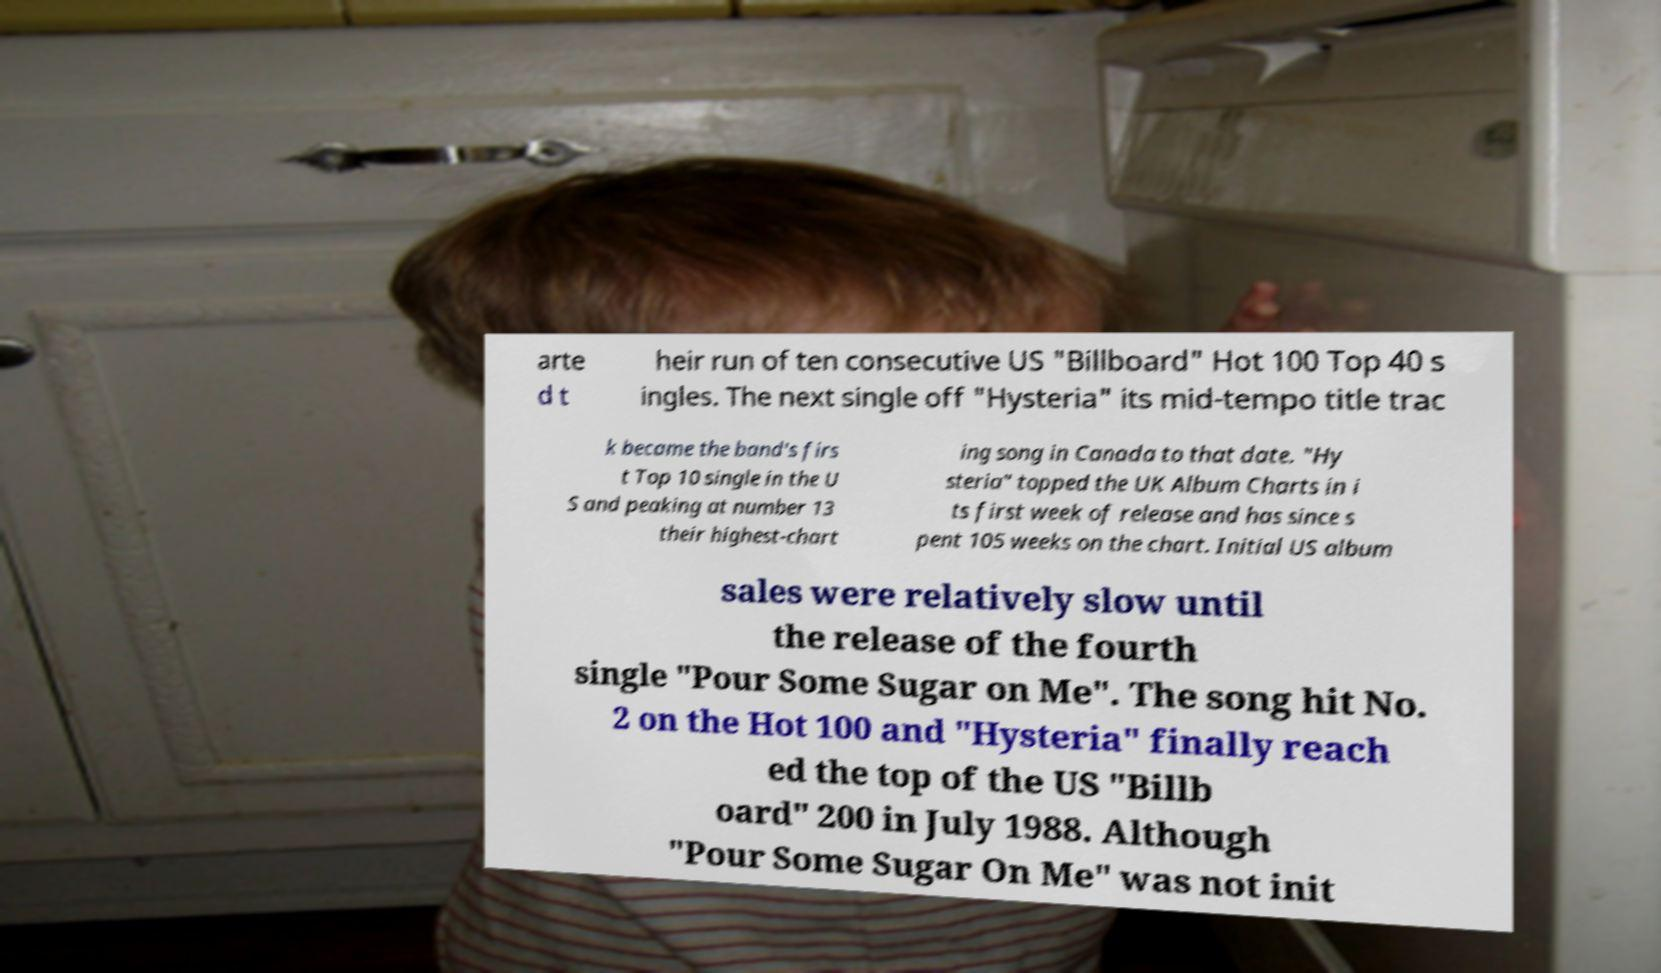I need the written content from this picture converted into text. Can you do that? arte d t heir run of ten consecutive US "Billboard" Hot 100 Top 40 s ingles. The next single off "Hysteria" its mid-tempo title trac k became the band's firs t Top 10 single in the U S and peaking at number 13 their highest-chart ing song in Canada to that date. "Hy steria" topped the UK Album Charts in i ts first week of release and has since s pent 105 weeks on the chart. Initial US album sales were relatively slow until the release of the fourth single "Pour Some Sugar on Me". The song hit No. 2 on the Hot 100 and "Hysteria" finally reach ed the top of the US "Billb oard" 200 in July 1988. Although "Pour Some Sugar On Me" was not init 